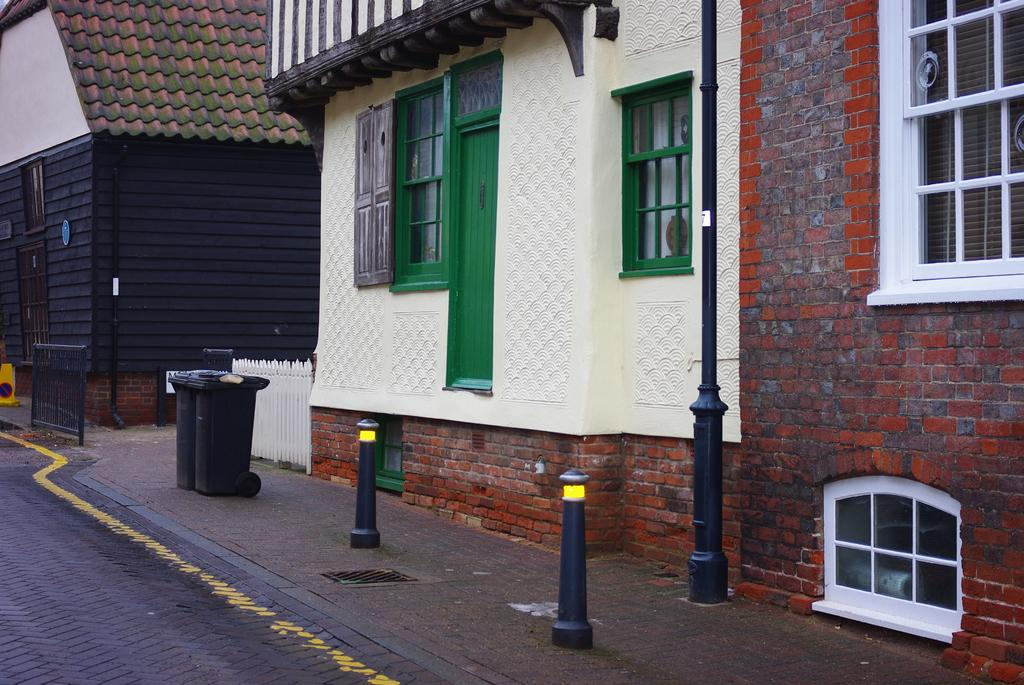What type of path is visible in the image? There is a walkway in the image. In which direction does the walkway lead? A: The walkway leads to the right. What structures can be seen in the image? There are poles, a dustbin, and buildings in the image. What features do the buildings have? The buildings have doors and windows. What is present on the left side of the image? There is a black railing on the left side of the image. What type of sand can be seen on the walkway in the image? There is no sand present on the walkway in the image. What is the temper of the buildings in the image? The temper of the buildings cannot be determined from the image, as buildings do not have emotions. 